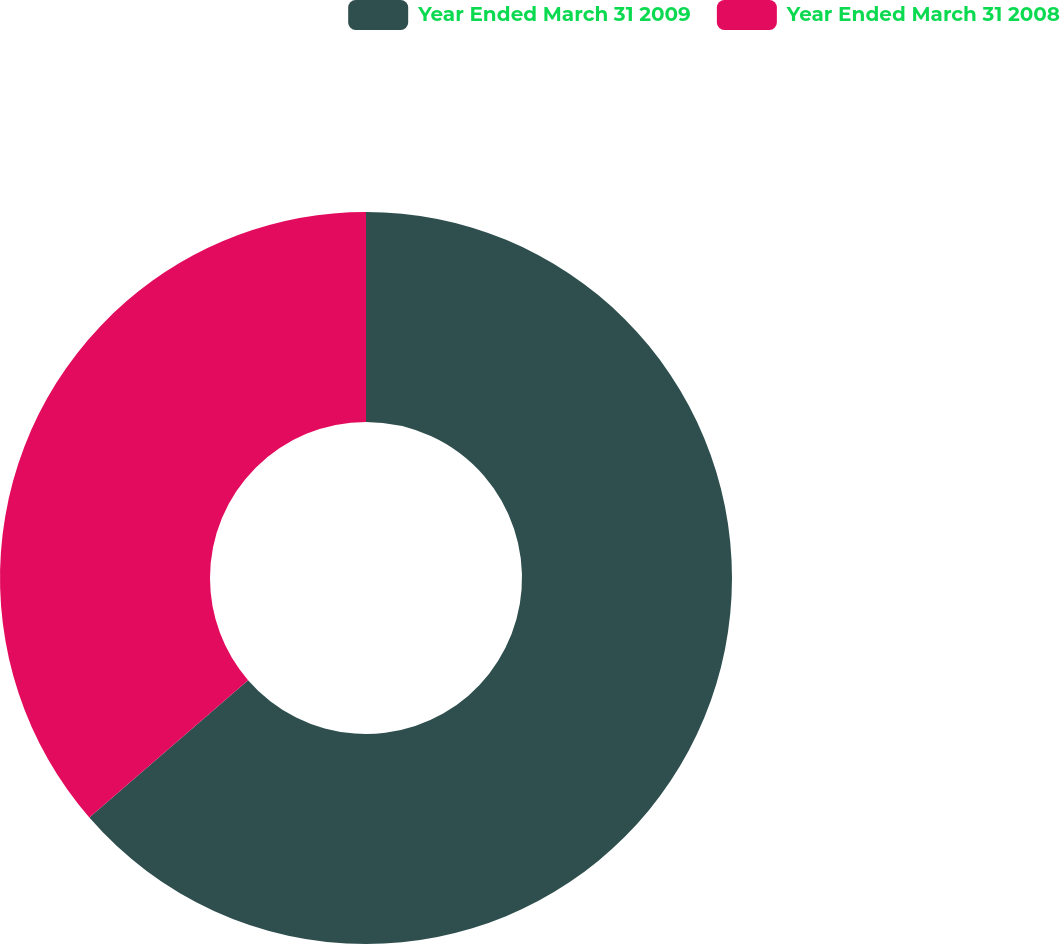<chart> <loc_0><loc_0><loc_500><loc_500><pie_chart><fcel>Year Ended March 31 2009<fcel>Year Ended March 31 2008<nl><fcel>63.64%<fcel>36.36%<nl></chart> 